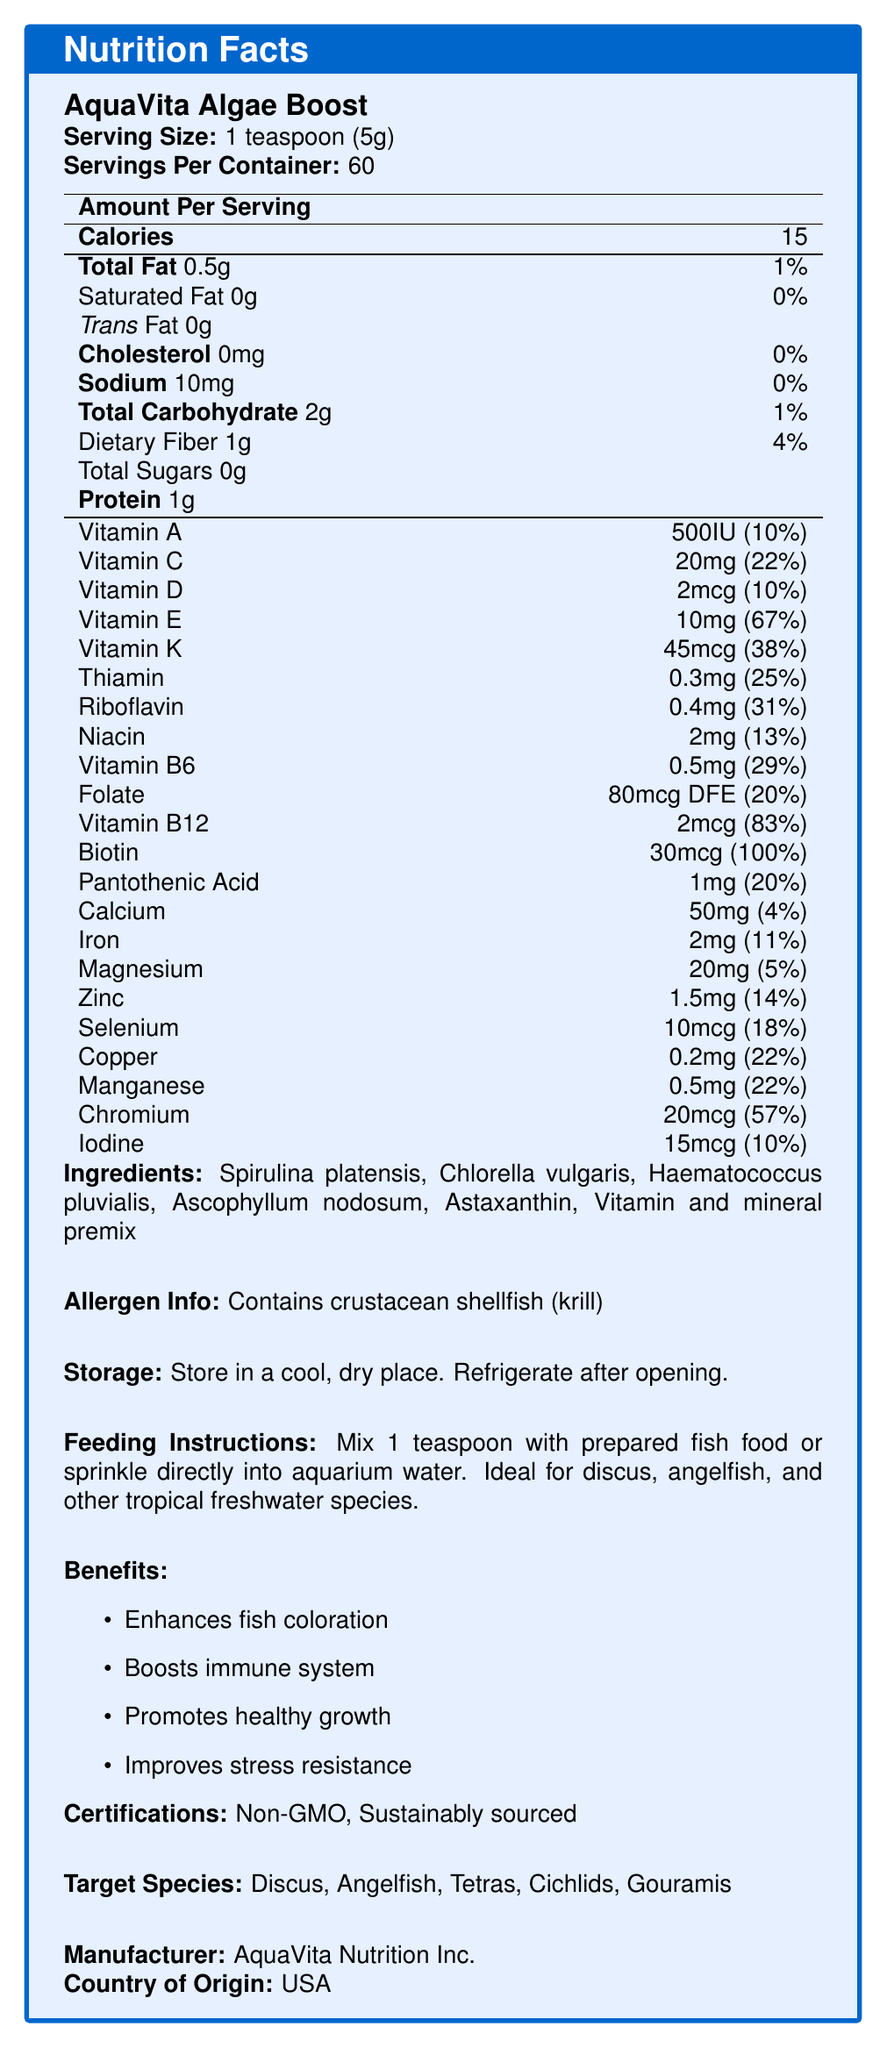what is the serving size of AquaVita Algae Boost? The serving size is listed as "1 teaspoon (5g)" in the document.
Answer: 1 teaspoon (5g) what are the main benefits of using AquaVita Algae Boost? The benefits section lists four main benefits: Enhances fish coloration, Boosts immune system, Promotes healthy growth, and Improves stress resistance.
Answer: Enhances fish coloration, Boosts immune system, Promotes healthy growth, Improves stress resistance how many calories are there per serving of AquaVita Algae Boost? The nutrition facts section states that there are 15 calories per serving.
Answer: 15 calories which vitamins are present in AquaVita Algae Boost and in what quantities? The nutrition facts section lists the various vitamins and their quantities per serving.
Answer: Vitamin A: 500IU, Vitamin C: 20mg, Vitamin D: 2mcg, Vitamin E: 10mg, Vitamin K: 45mcg, Thiamin: 0.3mg, Riboflavin: 0.4mg, Niacin: 2mg, Vitamin B6: 0.5mg, Folate: 80mcg, Vitamin B12: 2mcg, Biotin: 30mcg, Pantothenic Acid: 1mg who is the manufacturer of AquaVita Algae Boost? The manufacturer is listed as AquaVita Nutrition Inc.
Answer: AquaVita Nutrition Inc. where should AquaVita Algae Boost be stored after opening? The storage instructions indicate that the product should be stored in a cool, dry place and refrigerated after opening.
Answer: Refrigerate after opening which fish species are targeted by AquaVita Algae Boost? The target species listed are Discus, Angelfish, Tetras, Cichlids, and Gouramis.
Answer: Discus, Angelfish, Tetras, Cichlids, Gouramis how much protein is there per serving of AquaVita Algae Boost? The nutrition facts section states that there is 1g of protein per serving.
Answer: 1g which ingredient in AquaVita Algae Boost is a crustacean shellfish? A. Spirulina platensis B. Chlorella vulgaris C. Krill The allergen info states that the product contains crustacean shellfish (krill), making krill the correct answer.
Answer: C. Krill which vitamins are contained in the highest and lowest percentages of the daily value per serving? A. Vitamin A and Biotin B. Vitamin B12 and Vitamin D C. Biotin and Pantothenic Acid D. Vitamin E and Thiamin Based on the daily values listed: Biotin is 100%, the highest, and Pantothenic Acid is 20%, the lowest among the provided options.
Answer: C. Biotin and Pantothenic Acid is AquaVita Algae Boost non-GMO? The certifications section indicates that the product is non-GMO.
Answer: Yes summarize the main idea of the document. The document outlines the composition and benefits of AquaVita Algae Boost, including nutritional content, ingredient list, target species, and storage information, along with its certifications of being non-GMO and sustainably sourced.
Answer: The document provides detailed nutrition facts for AquaVita Algae Boost, an algae-based fish food supplement, highlighting its benefits, ingredients, allergen information, storage, and feeding instructions, as well as its certifications and target species. what percentage of the daily value of iron does AquaVita Algae Boost provide per serving? The nutrition facts section lists iron as providing 11% of the daily value per serving.
Answer: 11% how many servings are there per container of AquaVita Algae Boost? The document states that there are 60 servings per container.
Answer: 60 servings what kind of fats are completely absent in AquaVita Algae Boost? The nutrition facts mention that saturated fat and trans fat are both 0g per serving.
Answer: Saturated fat, Trans fat does AquaVita Algae Boost contain any sugars? The nutrition facts section states that total sugars are 0g.
Answer: No which vitamin, mineral, or compound percentage of daily value cannot be determined just by looking at the label? The document does not provide information on the daily value percentages of some compounds, such as Astaxanthin and other specific ingredients in the vitamin and mineral premix.
Answer: Cannot be determined 